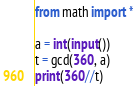<code> <loc_0><loc_0><loc_500><loc_500><_Python_>from math import *

a = int(input())
t = gcd(360, a)
print(360//t)
</code> 